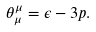Convert formula to latex. <formula><loc_0><loc_0><loc_500><loc_500>\theta _ { \mu } ^ { \mu } = \epsilon - 3 p .</formula> 